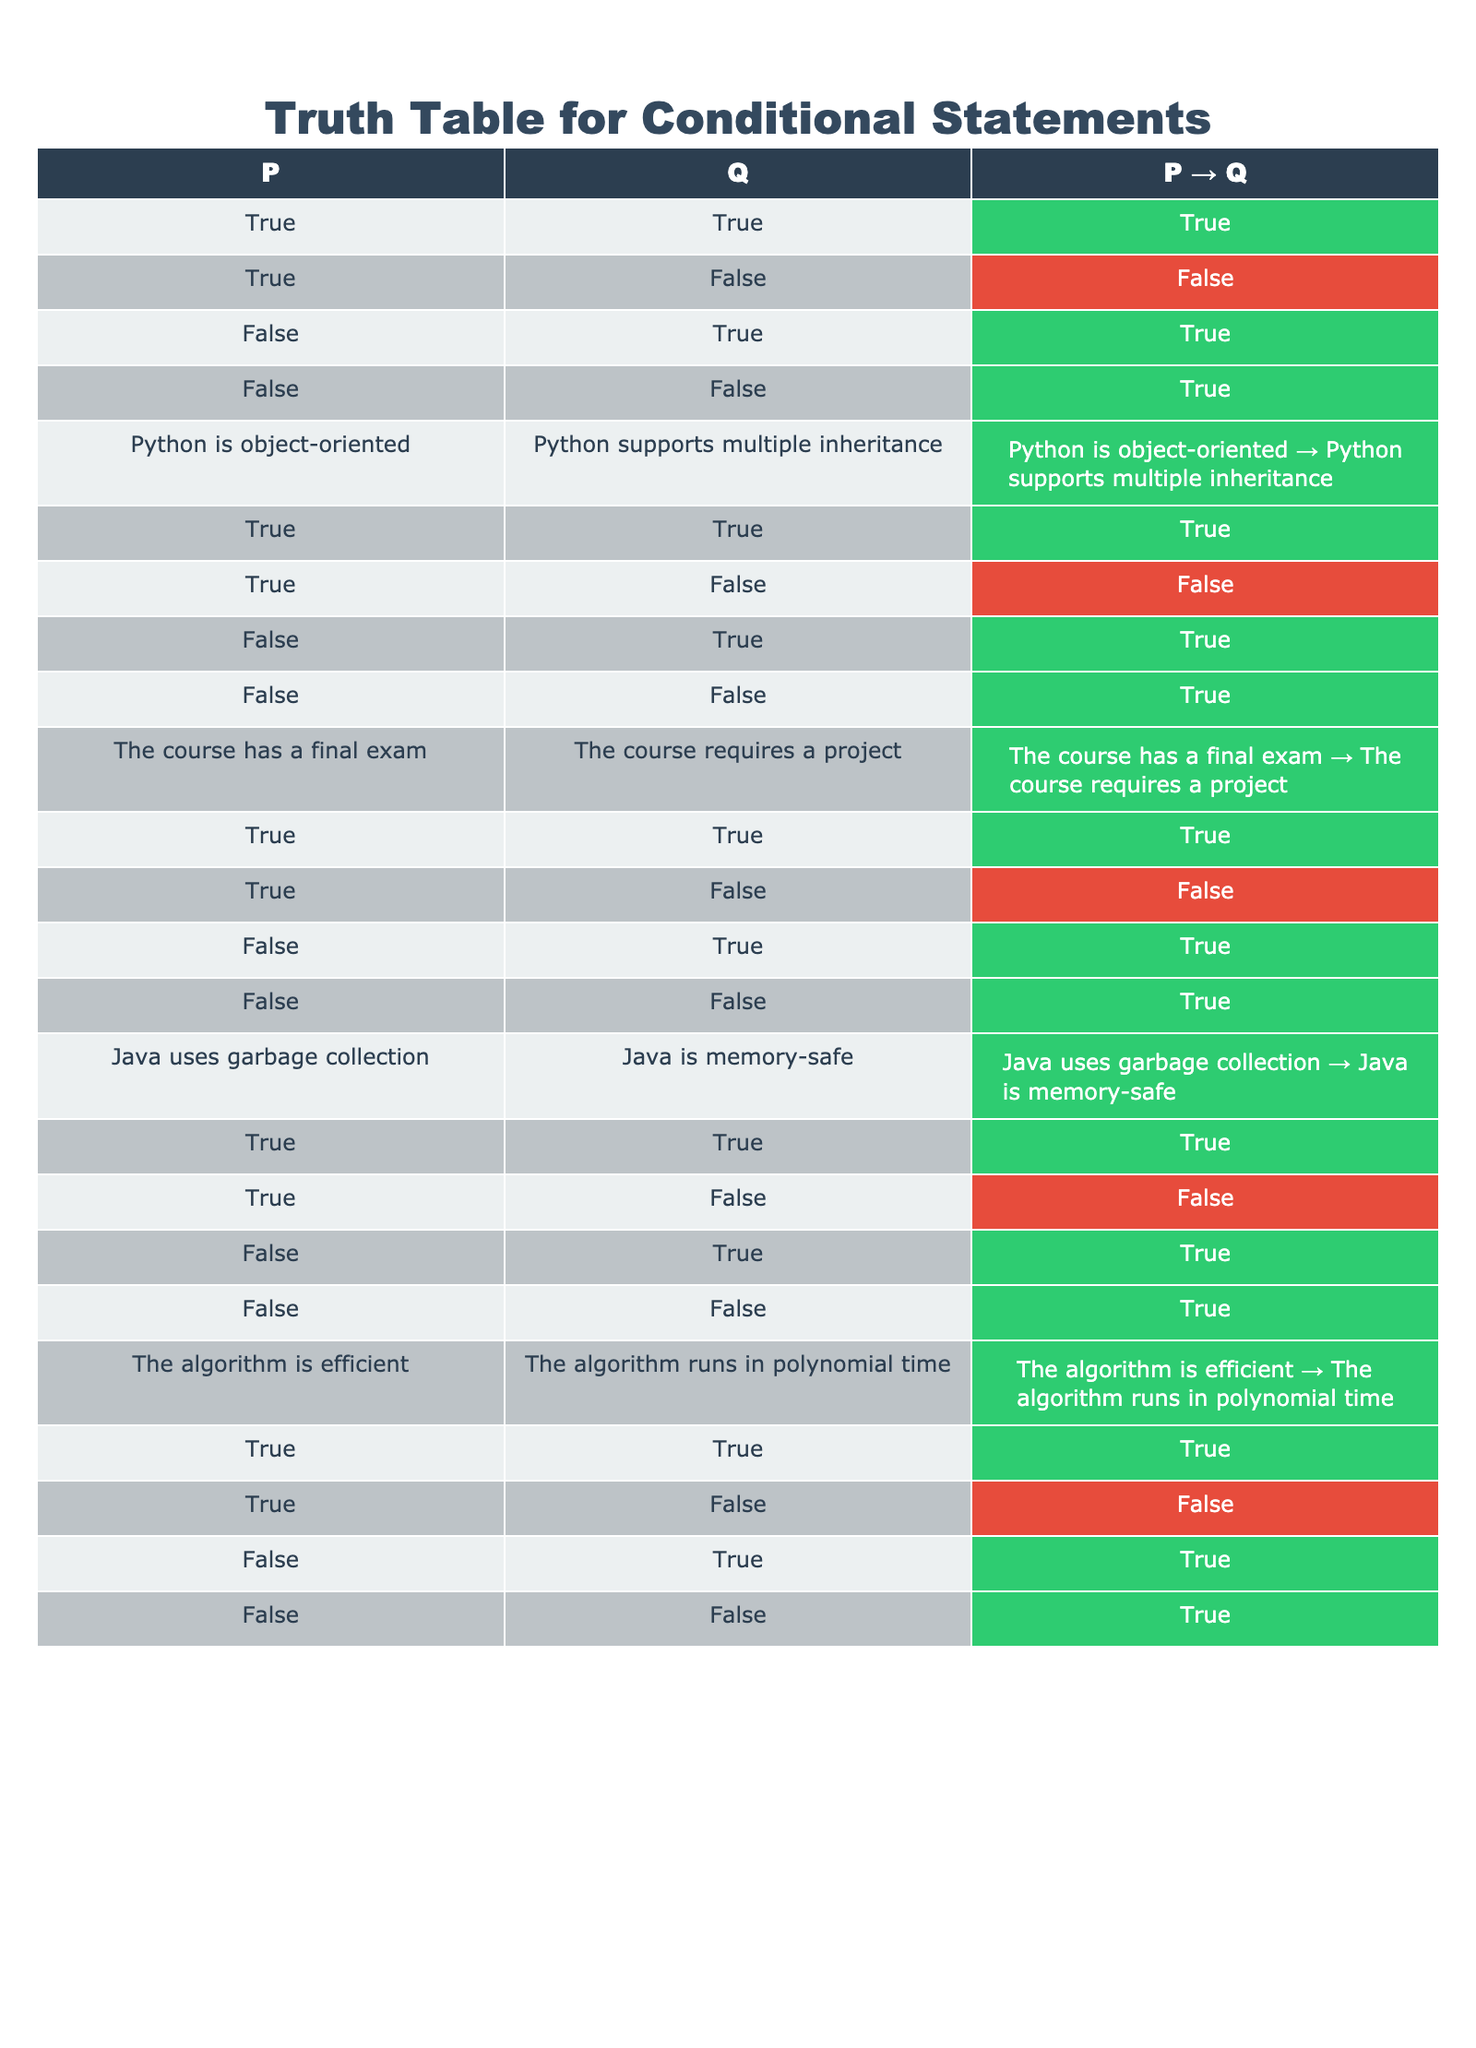What is the output when both P and Q are true? In the table, when both P and Q are true, the output for P → Q is true. This is shown in the first row of the table.
Answer: True What happens when P is true and Q is false? According to the table, when P is true and Q is false, the output for P → Q is false, as stated in the second row.
Answer: False How many total combinations are there for the truth values of P and Q? Looking through the table, there are 4 unique combinations for the truth values of P and Q, which are represented in each of the first four rows.
Answer: 4 Is the statement "If Python is object-oriented, then Python supports multiple inheritance" true? From the relevant row in the table, where both statements are true, the output for this conditional statement (Python is object-oriented → Python supports multiple inheritance) is true.
Answer: True If the course has a final exam, can we conclude that the course requires a project? The table indicates that when the course has a final exam, if it does not require a project, then the statement "The course has a final exam → The course requires a project" is false. Thus, we can’t conclude that it requires a project when there’s a final exam.
Answer: No What is the output for the statement "The algorithm is efficient" when it is false? According to the truth table, when "The algorithm is efficient" is false, the output for the statement "The algorithm is efficient → The algorithm runs in polynomial time" is always true, as shown in the last row.
Answer: True How many statements yield an output of true when P is false? When examining the rows where P is false (the third and fourth rows), we find both statements yield true outcomes, which means there are 3 statements where the output is true.
Answer: 3 Are there any cases where a true P leads to a false output for the conditional statement? As per the table, when P is true, the only scenario that results in a false output is when Q is false, specifically in the second row of the table.
Answer: Yes Which conditional statement has a true output with false antecedent? From the entries where the antecedent (P) is false, each corresponding statement outputs true, which is consistent across multiple rows of the table. Examples include "Java uses garbage collection → Java is memory-safe."
Answer: All statements with false antecedents output true 